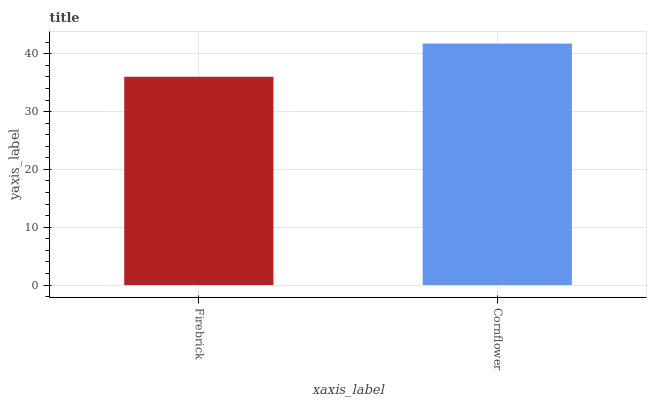Is Firebrick the minimum?
Answer yes or no. Yes. Is Cornflower the maximum?
Answer yes or no. Yes. Is Cornflower the minimum?
Answer yes or no. No. Is Cornflower greater than Firebrick?
Answer yes or no. Yes. Is Firebrick less than Cornflower?
Answer yes or no. Yes. Is Firebrick greater than Cornflower?
Answer yes or no. No. Is Cornflower less than Firebrick?
Answer yes or no. No. Is Cornflower the high median?
Answer yes or no. Yes. Is Firebrick the low median?
Answer yes or no. Yes. Is Firebrick the high median?
Answer yes or no. No. Is Cornflower the low median?
Answer yes or no. No. 